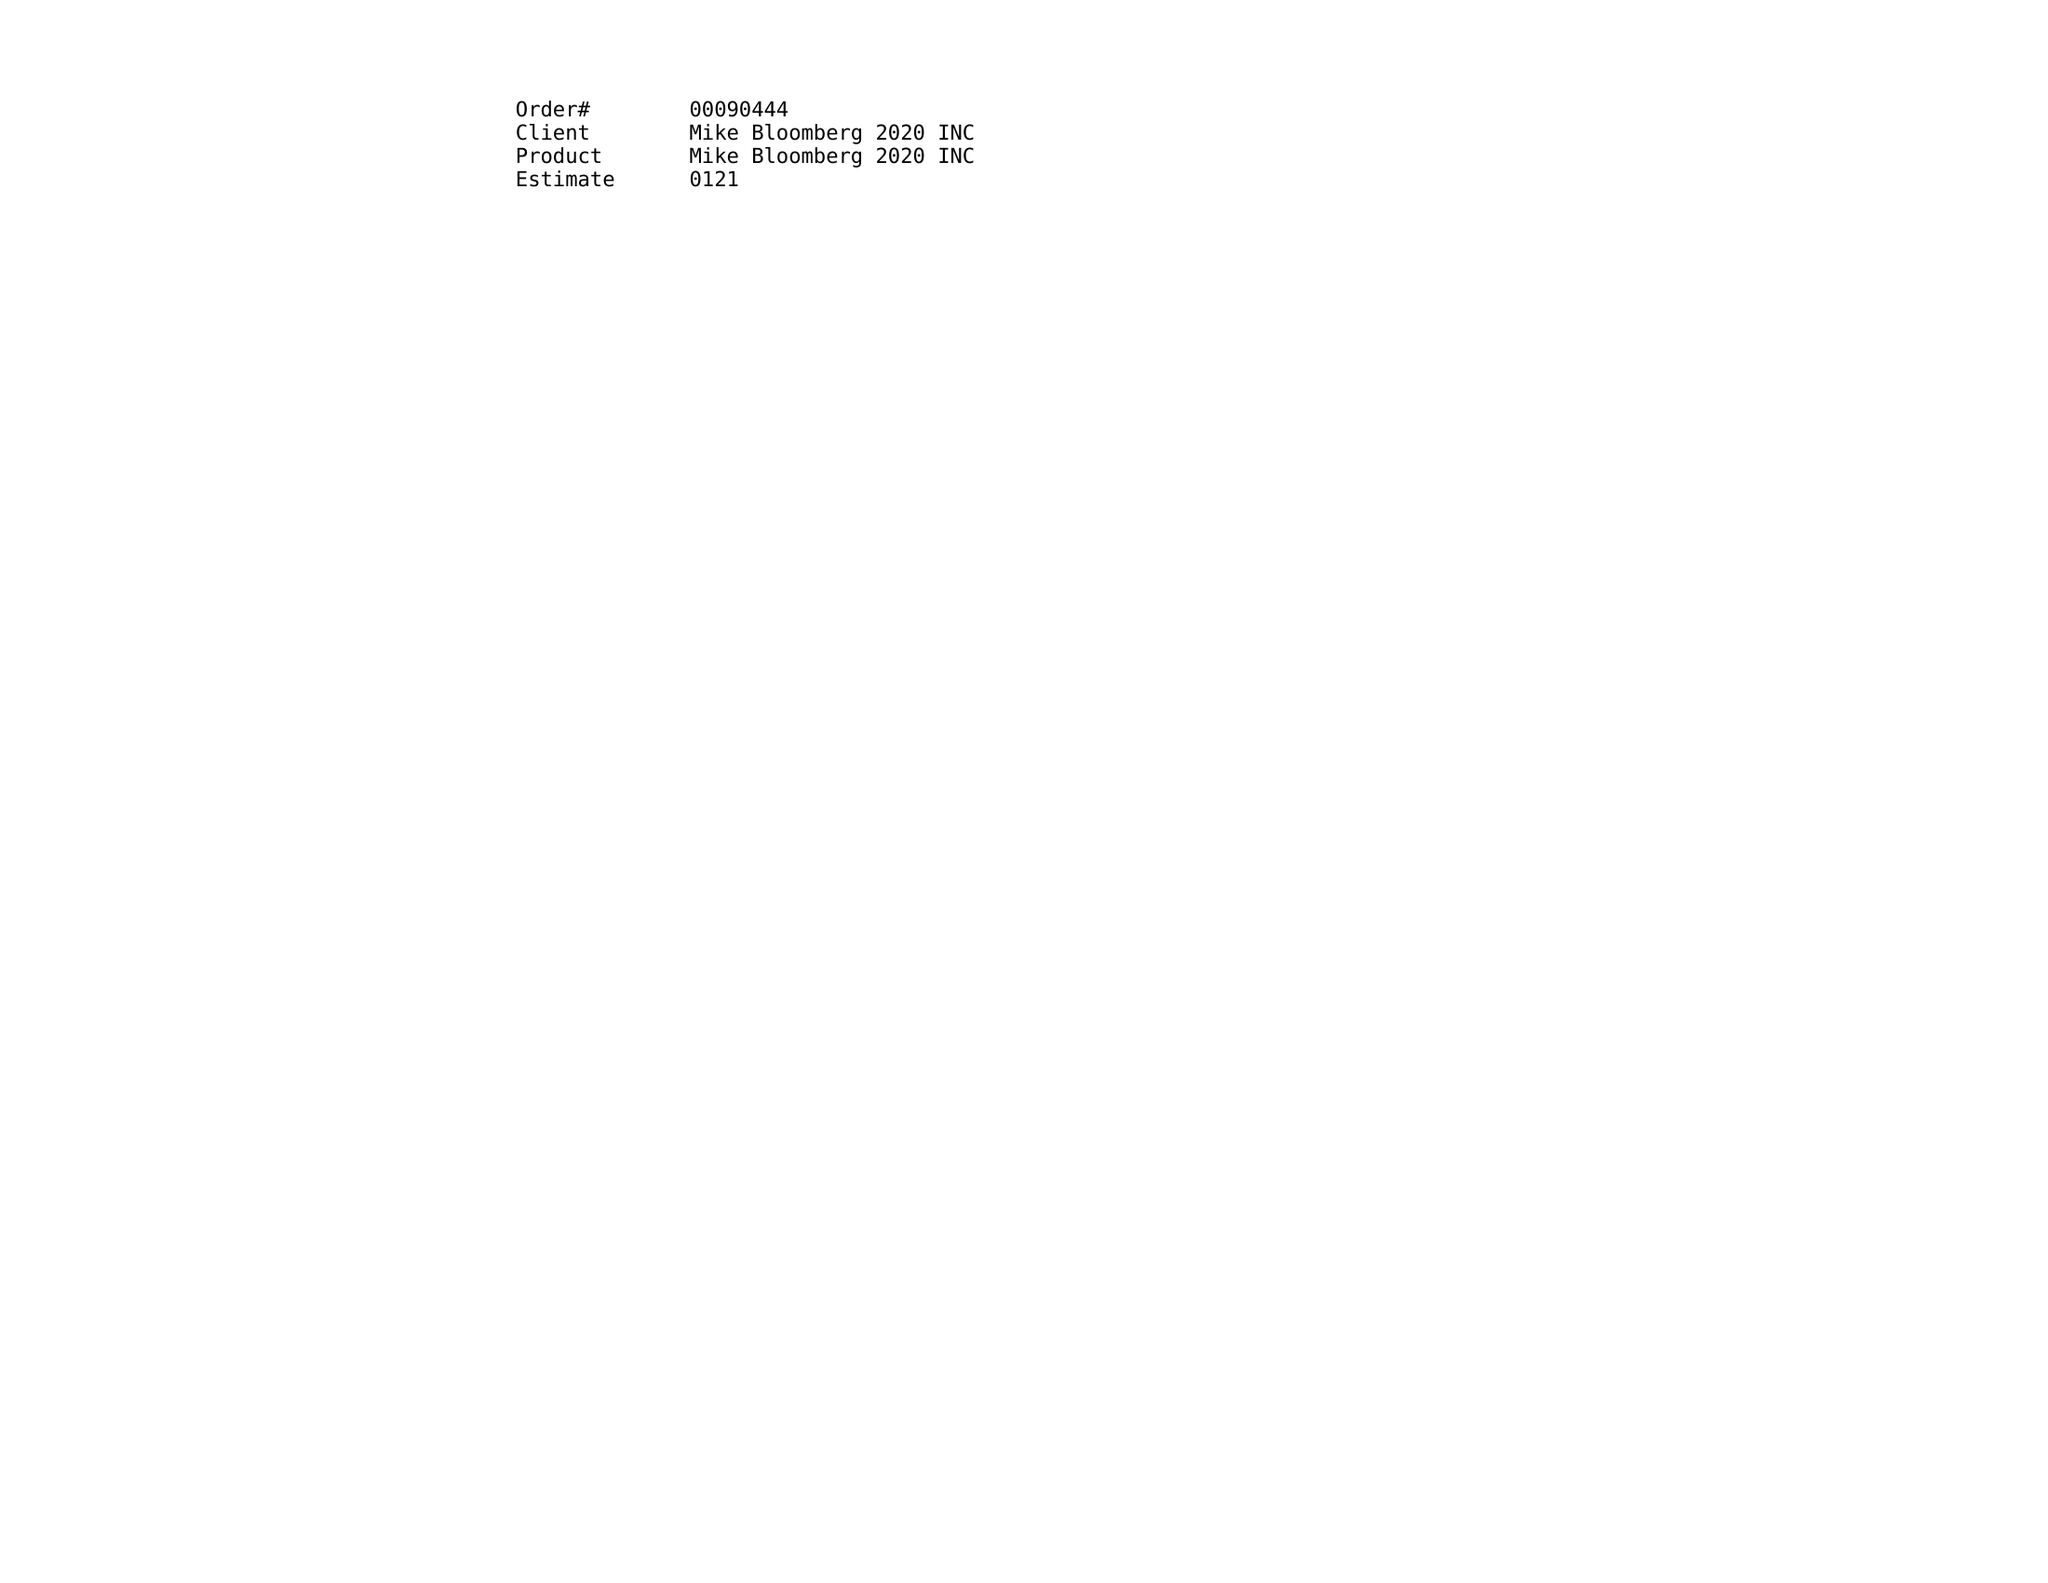What is the value for the advertiser?
Answer the question using a single word or phrase. MIKE BLOOMBERG 2020 INC 